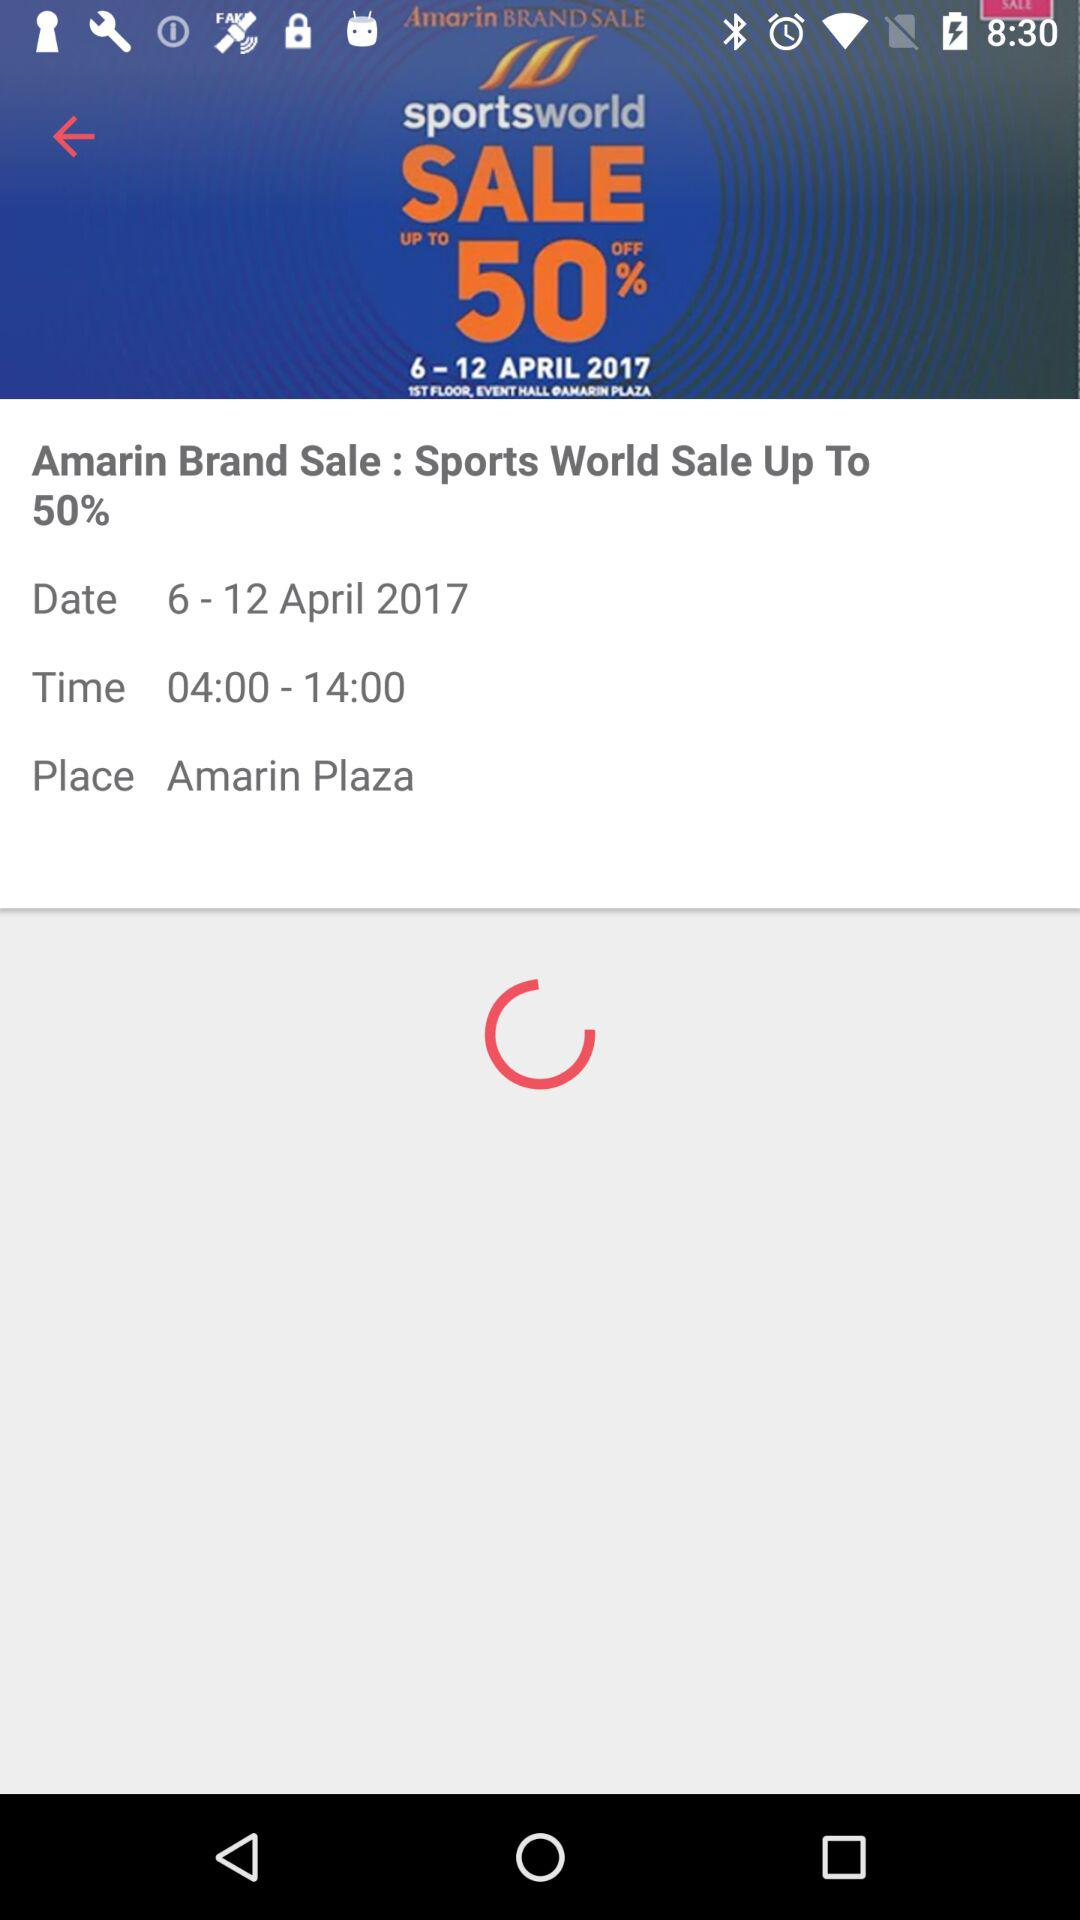What date range is displayed on the screen? The displayed date range is from April 6, 2017 to April 12, 2017. 